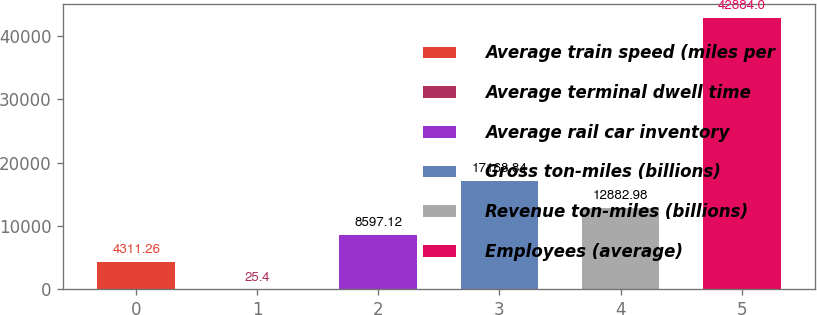<chart> <loc_0><loc_0><loc_500><loc_500><bar_chart><fcel>Average train speed (miles per<fcel>Average terminal dwell time<fcel>Average rail car inventory<fcel>Gross ton-miles (billions)<fcel>Revenue ton-miles (billions)<fcel>Employees (average)<nl><fcel>4311.26<fcel>25.4<fcel>8597.12<fcel>17168.8<fcel>12883<fcel>42884<nl></chart> 